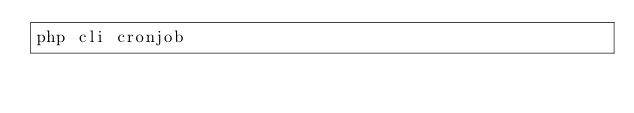Convert code to text. <code><loc_0><loc_0><loc_500><loc_500><_Bash_>php cli cronjob</code> 